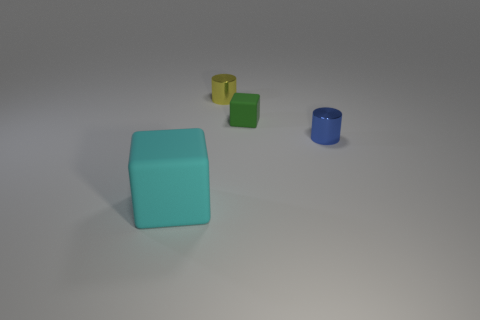The rubber object behind the rubber object that is left of the yellow metallic object is what shape?
Your answer should be compact. Cube. There is a small yellow thing; is its shape the same as the matte thing behind the small blue cylinder?
Your answer should be very brief. No. There is another shiny thing that is the same size as the blue metal object; what is its color?
Provide a short and direct response. Yellow. Is the number of cylinders that are in front of the tiny green object less than the number of large objects right of the cyan block?
Offer a very short reply. No. The rubber object that is in front of the thing that is on the right side of the matte cube that is behind the big cyan block is what shape?
Provide a short and direct response. Cube. Does the small shiny object behind the blue thing have the same color as the tiny thing in front of the tiny green rubber cube?
Make the answer very short. No. What number of shiny things are small objects or large cyan blocks?
Offer a very short reply. 2. What color is the shiny cylinder that is behind the blue shiny object in front of the block that is right of the big cyan rubber object?
Offer a terse response. Yellow. What is the color of the other small thing that is the same shape as the tiny yellow metal thing?
Keep it short and to the point. Blue. Is there any other thing of the same color as the tiny cube?
Your response must be concise. No. 